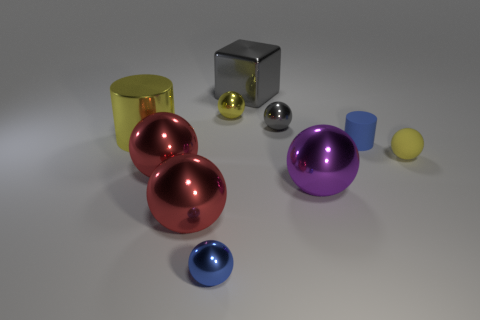Subtract all gray balls. How many balls are left? 6 Subtract all blue spheres. How many spheres are left? 6 Subtract all brown balls. Subtract all red cylinders. How many balls are left? 7 Subtract all spheres. How many objects are left? 3 Add 4 blue balls. How many blue balls exist? 5 Subtract 0 green cylinders. How many objects are left? 10 Subtract all tiny brown metallic cylinders. Subtract all big cubes. How many objects are left? 9 Add 2 blue matte things. How many blue matte things are left? 3 